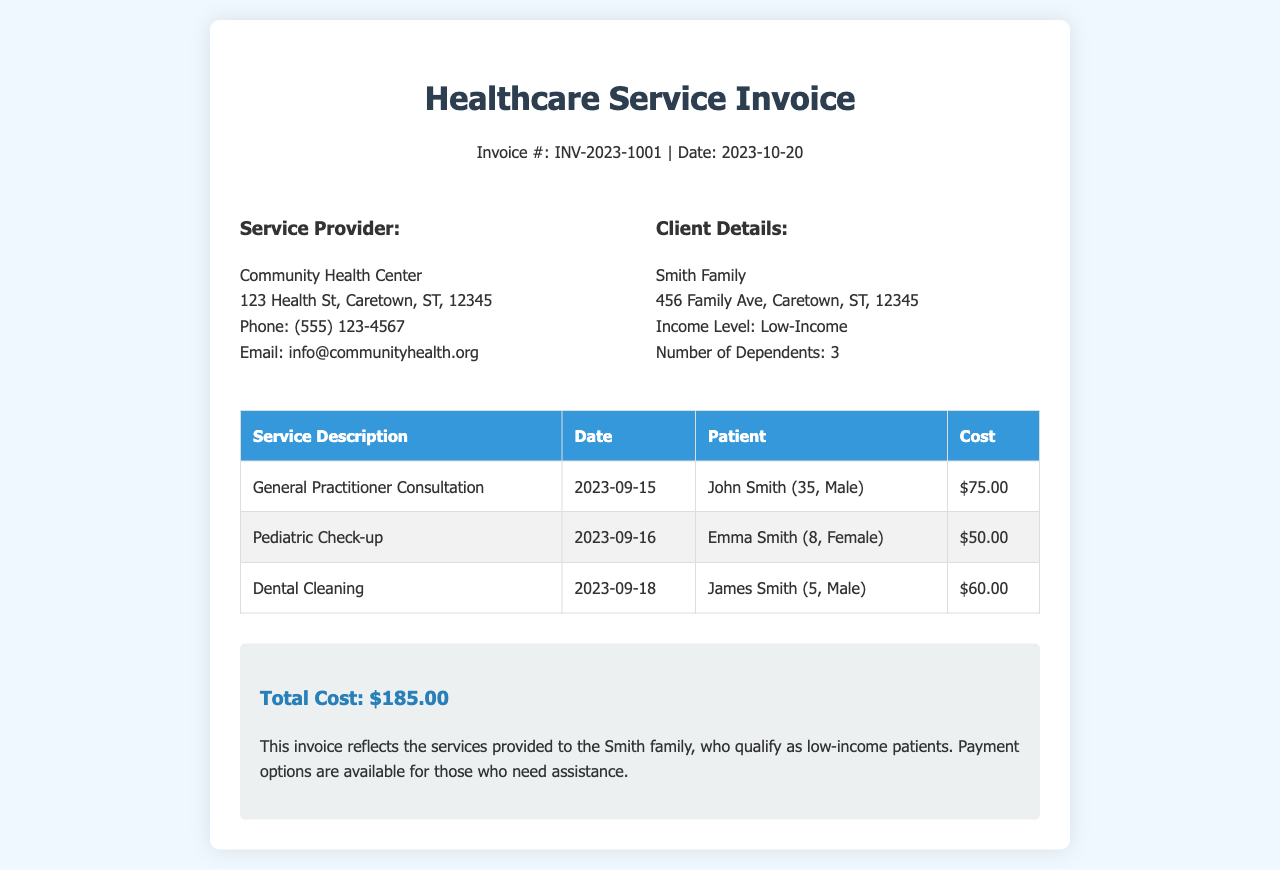What is the invoice number? The invoice number is displayed prominently in the header of the document.
Answer: INV-2023-1001 What is the total cost of services? The total cost is summarized at the bottom of the invoice in the summary section.
Answer: $185.00 Who is the service provider? The service provider's name and contact details are listed in the invoice details section.
Answer: Community Health Center What services were provided on September 16? The date is listed in the services table, along with corresponding service descriptions.
Answer: Pediatric Check-up How many dependents does the Smith family have? The answer is specified in the client details of the invoice.
Answer: 3 What type of consultation was provided? Different service descriptions are present in the services table, including the type of consultation.
Answer: General Practitioner Consultation Which patient had a dental cleaning? The patient's name is associated with the corresponding service in the services table.
Answer: James Smith What is the income level of the Smith family? The income level is outlined in the client details section of the document.
Answer: Low-Income What is the date of service for the general practitioner consultation? The date can be found in the services table next to the service description.
Answer: 2023-09-15 